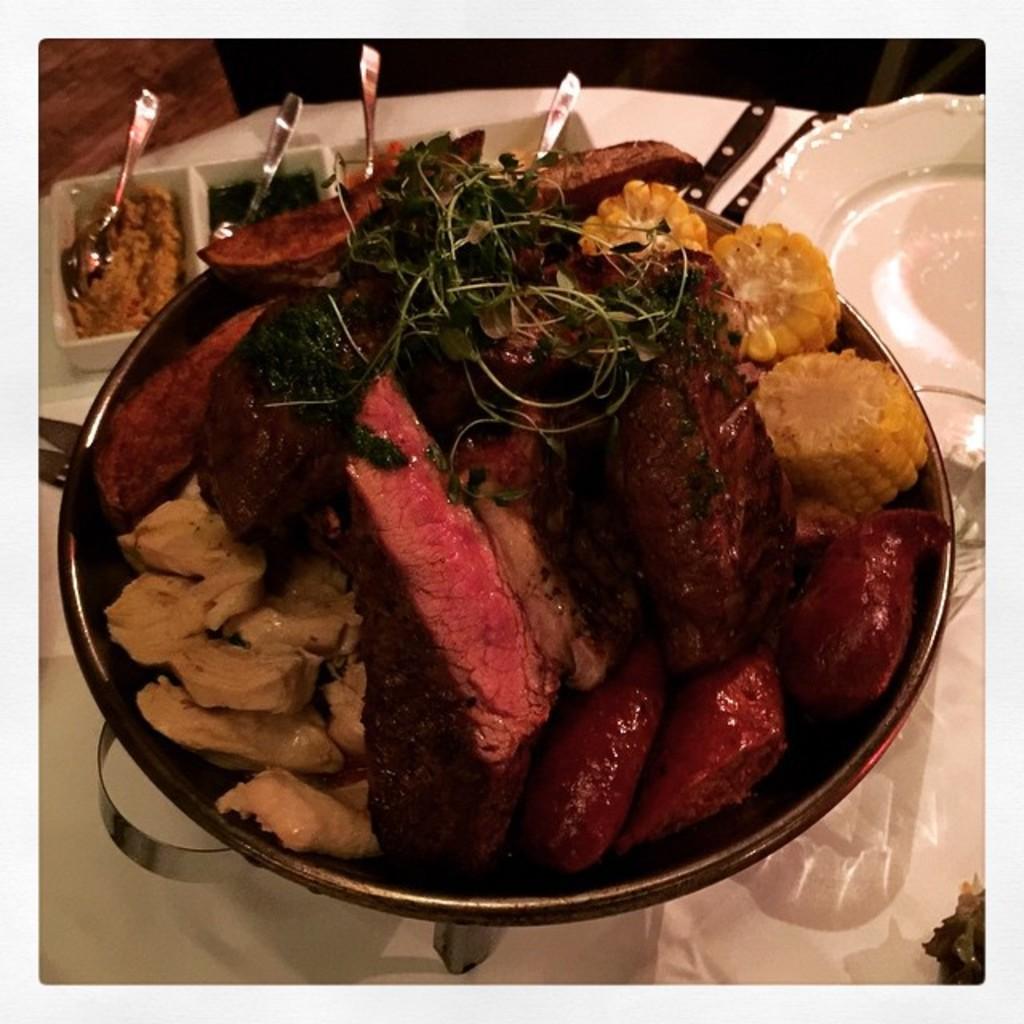How would you summarize this image in a sentence or two? In the image we can see there are meat items in the bowl and there are spoons kept in a plate. 